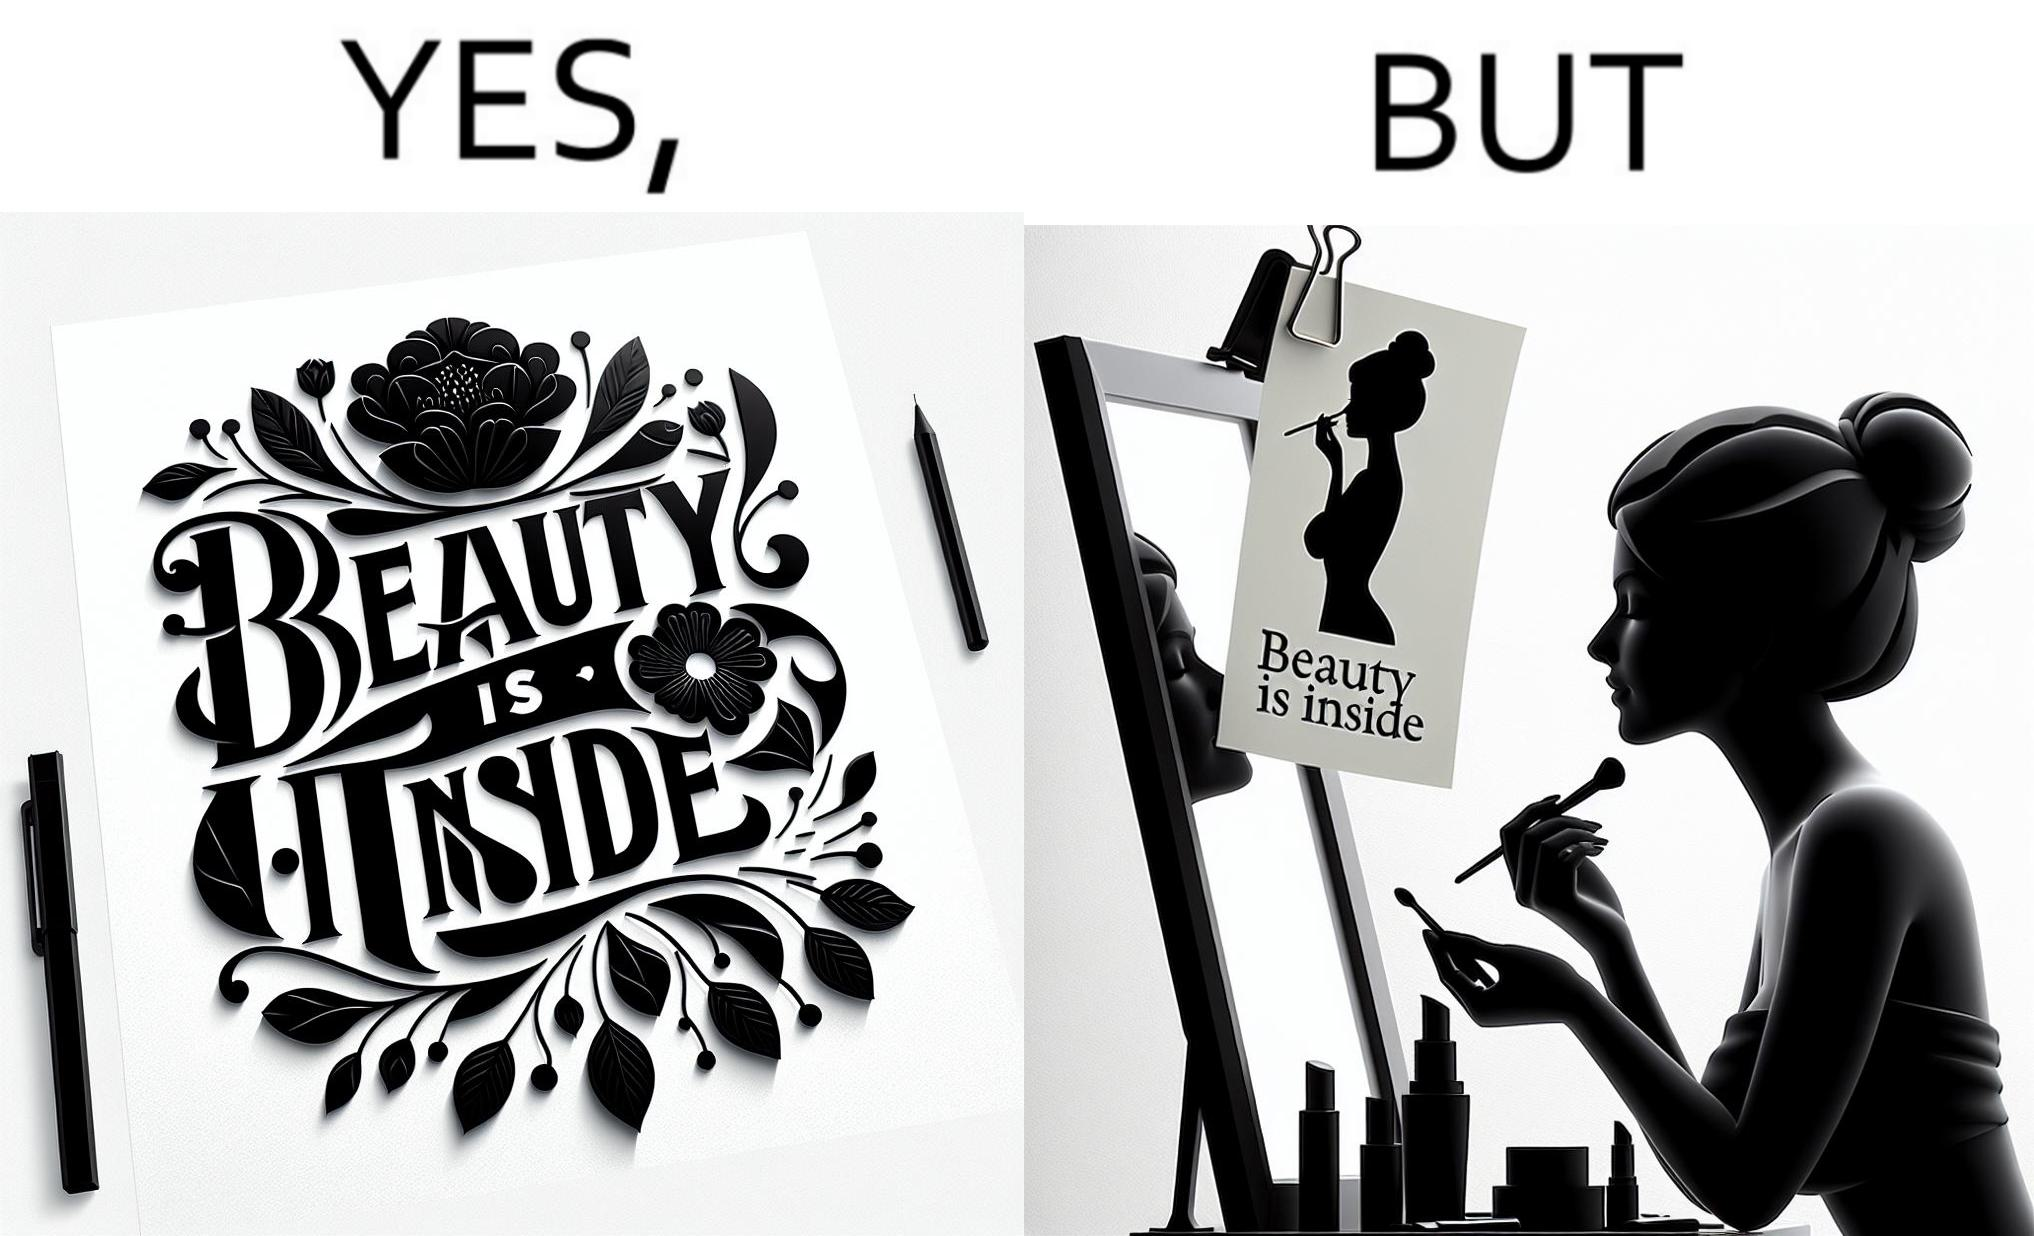Describe what you see in this image. The image is satirical because while the text on the paper says that beauty lies inside, the woman ignores the note and continues to apply makeup to improve her outer beauty. 